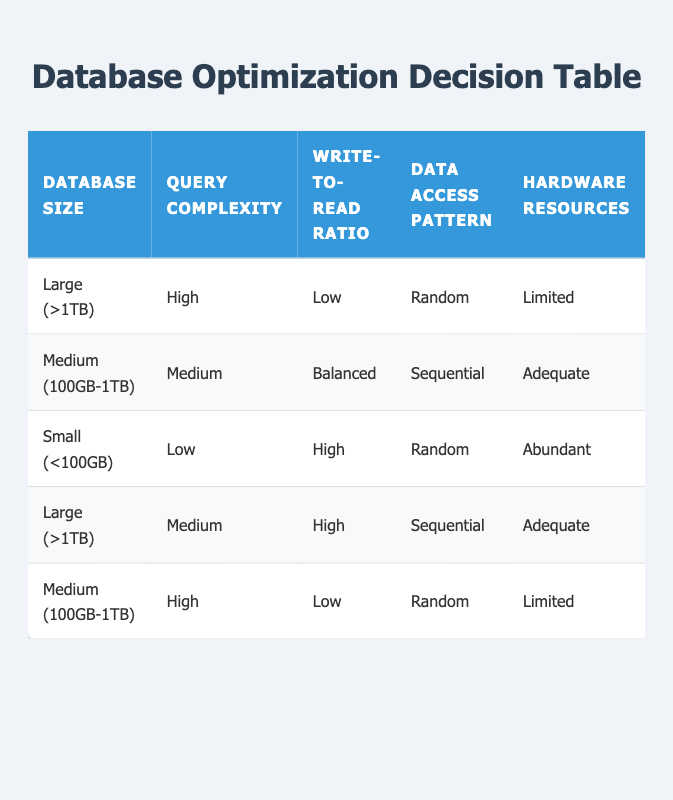What actions should be taken for a large database with high query complexity, low write-to-read ratio, random data access pattern, and limited hardware resources? Referring to the table, for a database size of 'Large (>1TB)', query complexity 'High', write-to-read ratio 'Low', data access pattern 'Random', and hardware resources 'Limited', the suggested actions are: Implement Indexing (True), Use Query Caching (True), Partition Data (True), Normalize/Denormalize (Denormalize), and Upgrade Hardware (True).
Answer: Implement Indexing, Use Query Caching, Partition Data, Denormalize, Upgrade Hardware Is partitioning data recommended for a medium-sized database with medium complexity and a balanced write-to-read ratio? Based on the table, for a medium-sized database (100GB-1TB) with medium query complexity, balanced write-to-read ratio, sequential data access pattern, and adequate hardware resources, partitioning data is not advisable as it shows 'False' in the corresponding column.
Answer: No What is the write-to-read ratio for a small database with a low query complexity and abundant hardware resources? Looking at the data for small databases (<100GB), the write-to-read ratio is high according to the table, indicating that more writing operations occur in comparison to read operations.
Answer: High How many actions recommend upgrading hardware for large databases? In total, there are three actions listed for large databases in the table that recommend upgrading hardware: the first rule (when database size is large, query complexity is high, etc.), and the fourth rule (medium query complexity and high write-to-read ratio). Therefore, upgrading hardware is recommended in both cases.
Answer: 2 Is normalization suggested for a medium database with low write-to-read ratio and random access pattern? Yes, looking at the rules for medium-sized databases with high query complexity, low write-to-read ratio, random access pattern, and limited hardware resources, normalization is suggested as per the table showing 'Normalize' in the action column.
Answer: Yes What percentage of actions recommend using query caching for small databases? Query caching is not recommended for small databases according to the table, as it shows 'False' for all instances of small databases, meaning the percentage of actions that recommend it is 0%.
Answer: 0% How does the data access pattern impact the recommendation to implement indexing for medium databases with high query complexity? For medium databases (100GB-1TB) with high query complexity, the data access pattern is sequential, which leads to the recommendation to implement indexing as indicated by 'True' in the table. This means that although the complexity is high, a sequential pattern allows for indexing to be beneficial.
Answer: It allows indexing to be beneficial How many rules suggest denormalization for large databases? From the table, there are two rules that suggest denormalization for large databases: the first rule for high complexity, low write-to-read ratio, and the second for medium complexity and high write-to-read ratio. Therefore, the total number of recommendations for denormalization is two.
Answer: 2 